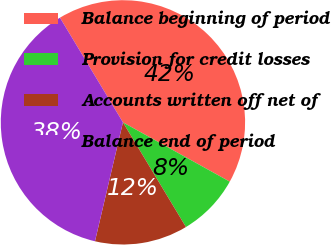Convert chart. <chart><loc_0><loc_0><loc_500><loc_500><pie_chart><fcel>Balance beginning of period<fcel>Provision for credit losses<fcel>Accounts written off net of<fcel>Balance end of period<nl><fcel>41.69%<fcel>8.31%<fcel>12.3%<fcel>37.7%<nl></chart> 